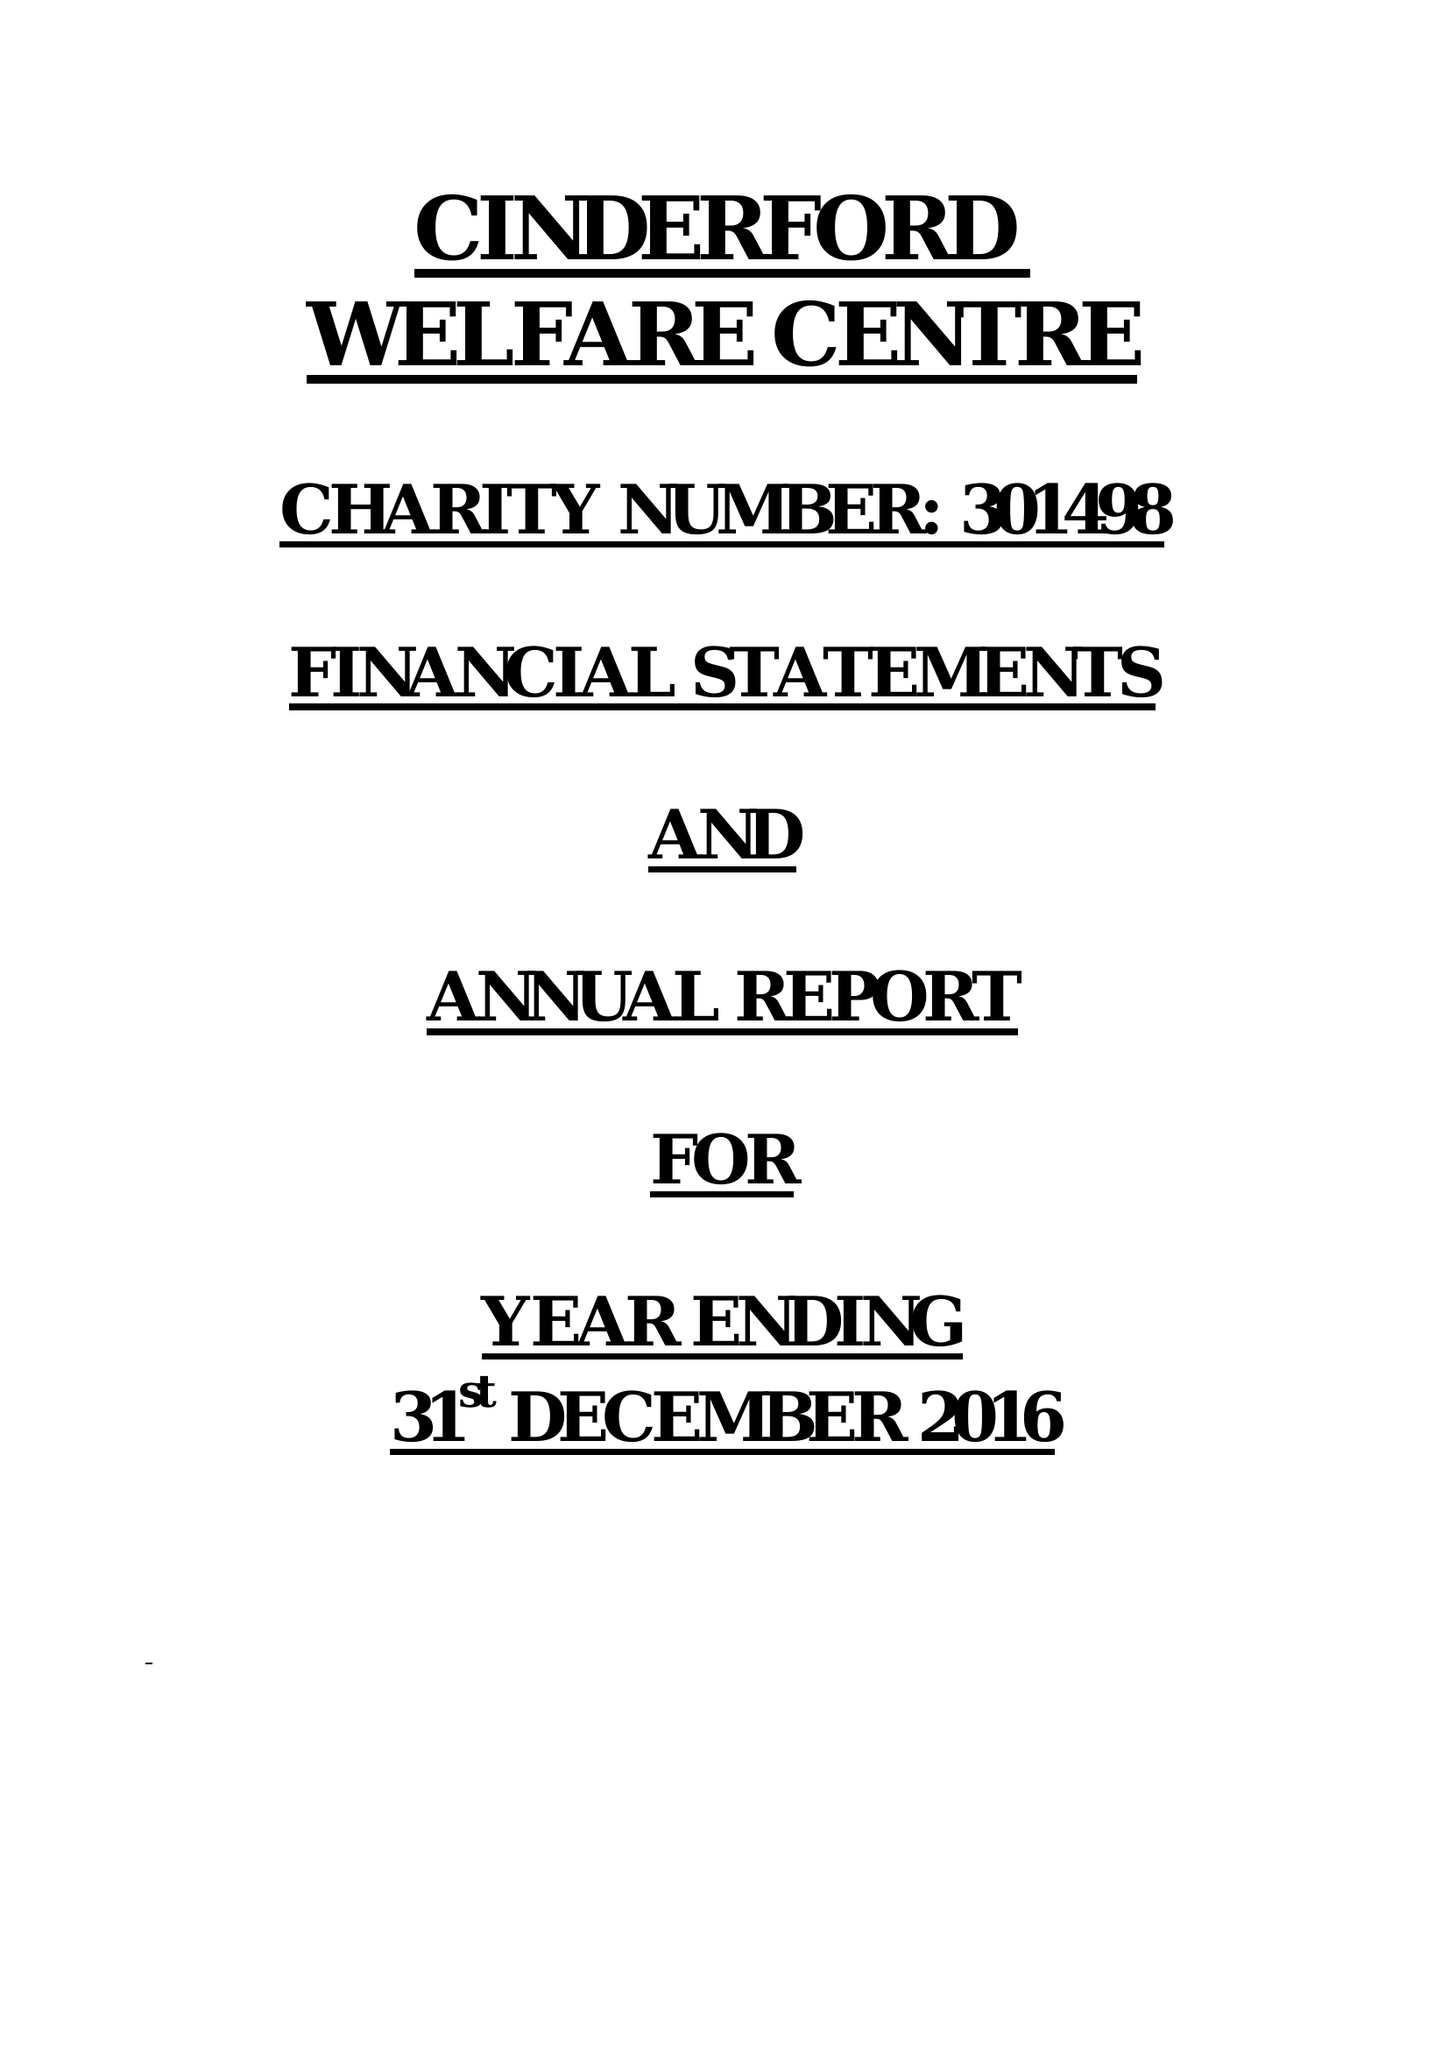What is the value for the report_date?
Answer the question using a single word or phrase. 2016-12-31 